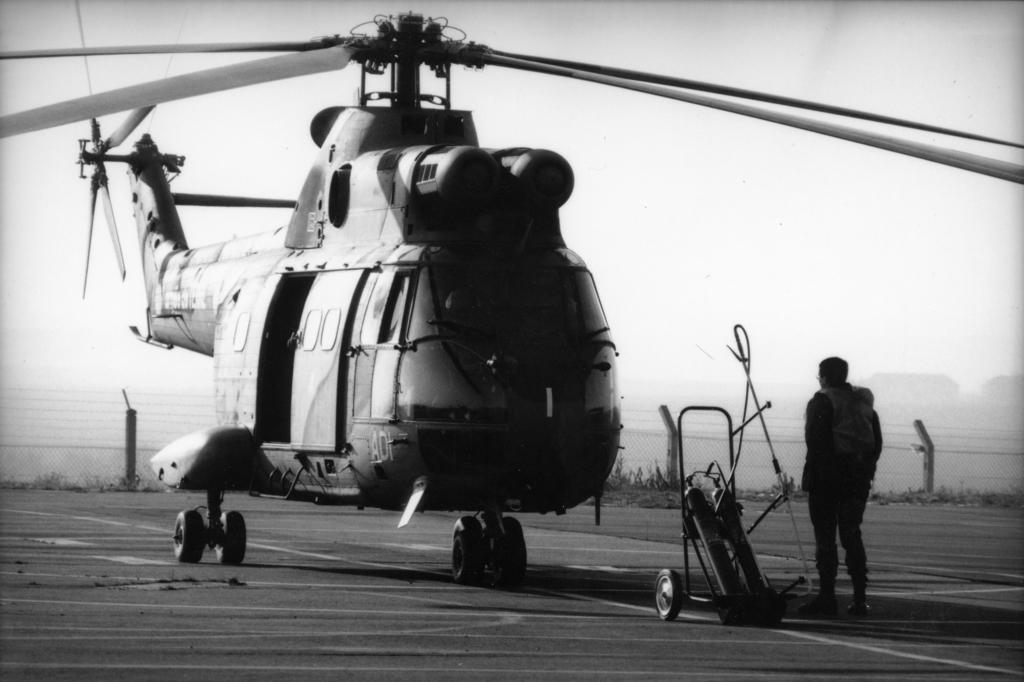What is the main subject in the image? There is a person standing in the image. What object related to medical care can be seen in the image? There is an oxygen cylinder trolley in the image. What type of vehicle is present in the image? There is a helicopter in the image. What can be seen in the background of the image? There are poles and the sky visible in the background of the image. What type of whip is being used in the image? There is no whip present in the image. 